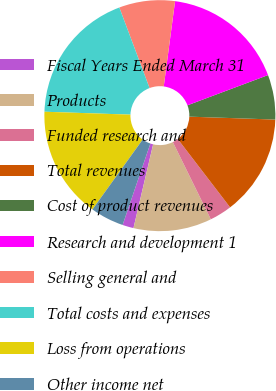Convert chart. <chart><loc_0><loc_0><loc_500><loc_500><pie_chart><fcel>Fiscal Years Ended March 31<fcel>Products<fcel>Funded research and<fcel>Total revenues<fcel>Cost of product revenues<fcel>Research and development 1<fcel>Selling general and<fcel>Total costs and expenses<fcel>Loss from operations<fcel>Other income net<nl><fcel>1.56%<fcel>10.94%<fcel>3.13%<fcel>14.06%<fcel>6.25%<fcel>17.19%<fcel>7.81%<fcel>18.75%<fcel>15.62%<fcel>4.69%<nl></chart> 